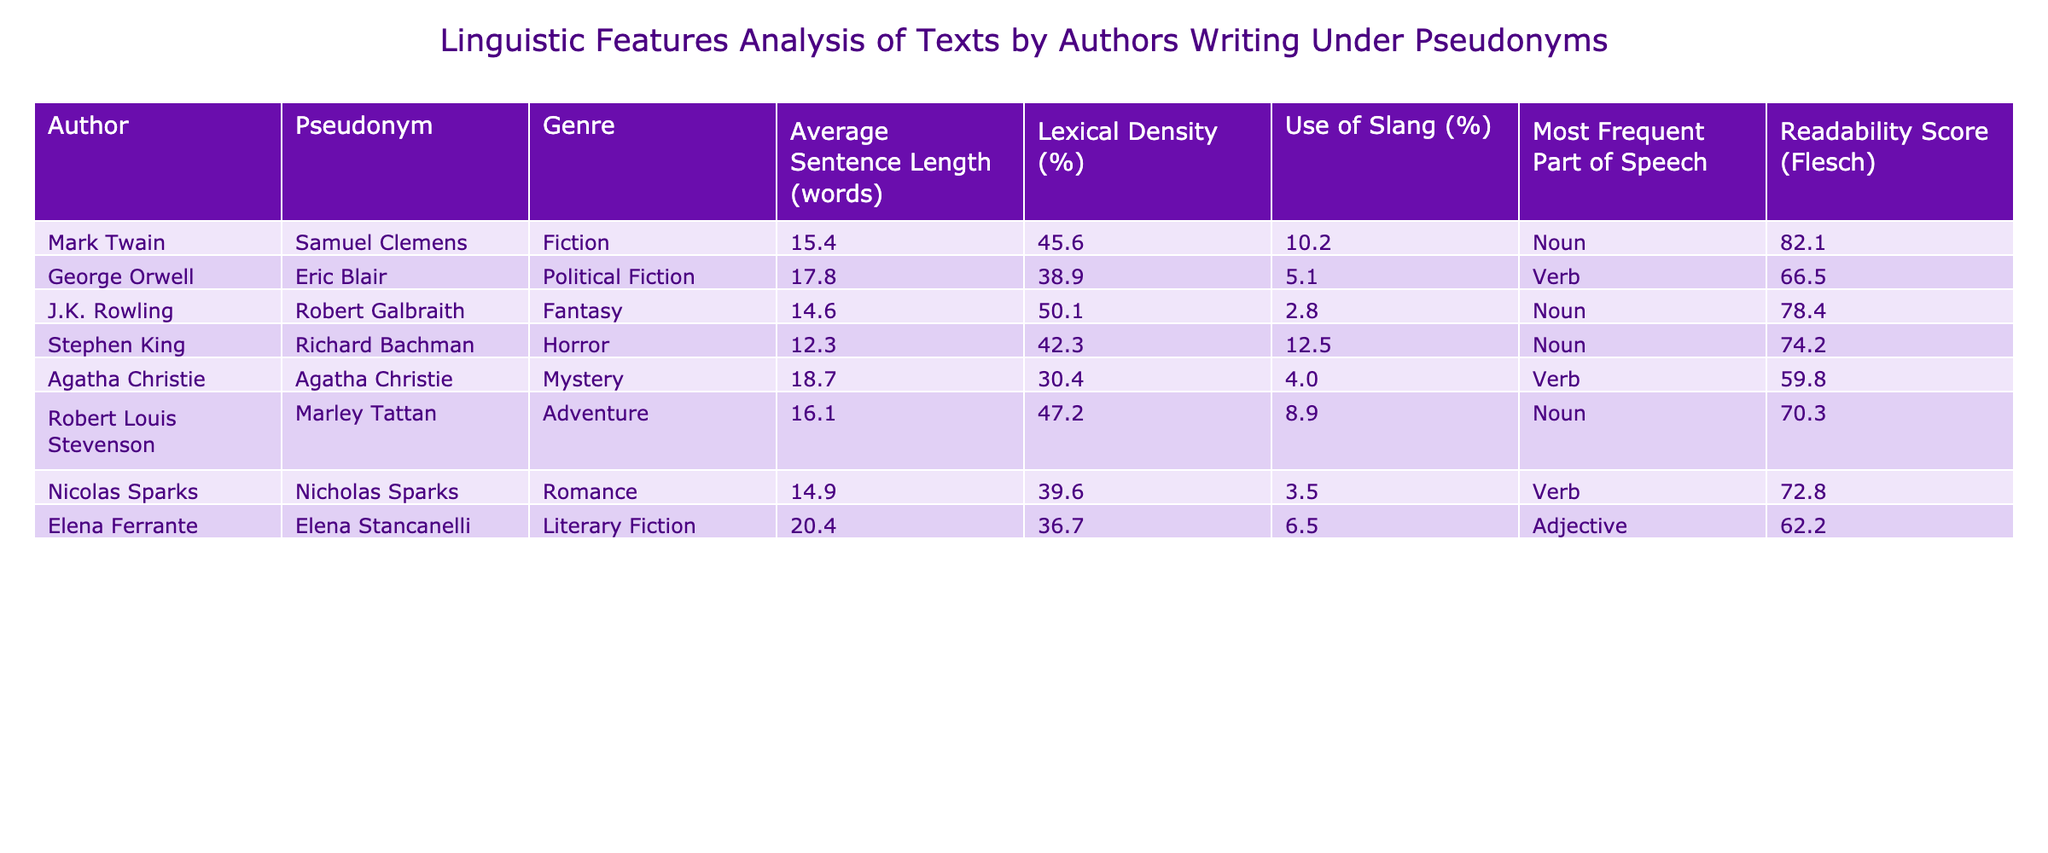What is the average sentence length for J.K. Rowling's pseudonym? According to the table, J.K. Rowling, using the pseudonym Robert Galbraith, has an average sentence length of 14.6 words.
Answer: 14.6 Which genre has the highest readability score? By comparing the readability scores across all genres in the table, the highest score is 82.1 for Mark Twain's work in Fiction.
Answer: 82.1 Does Elena Ferrante use more slang compared to Stephen King? The table indicates that Elena Ferrante (6.5%) uses more slang than Stephen King (12.5%). Hence, the statement is false.
Answer: No What is the difference in lexical density between Agatha Christie and Robert Louis Stevenson? Agatha Christie has a lexical density of 30.4%, while Robert Louis Stevenson has 47.2%. The difference is calculated as 47.2 - 30.4 = 16.8.
Answer: 16.8 Which author has the lowest average sentence length in the horror genre? In the table, Stephen King, writing as Richard Bachman, has the lowest average sentence length of 12.3 words among the listed authors in the horror genre.
Answer: 12.3 Is the most frequent part of speech for George Orwell a noun? The table shows that George Orwell's most frequent part of speech is a verb, hence the statement is false.
Answer: No What is the average readability score for the authors writing under a pseudonym? The readability scores are 82.1, 66.5, 78.4, 74.2, 59.8, 70.3, 72.8, and 62.2. To find the average, add these scores together (82.1 + 66.5 + 78.4 + 74.2 + 59.8 + 70.3 + 72.8 + 62.2 = 586.3) and divide by 8, resulting in an average readability score of 73.29.
Answer: 73.3 Which author writing under a pseudonym has the highest use of slang and in what genre? The author with the highest use of slang is Stephen King, writing as Richard Bachman, with 12.5% in the horror genre.
Answer: Stephen King, Horror, 12.5% How many authors in the table have a readability score below 70? From the table, the authors with a readability score below 70 are Agatha Christie (59.8), Elena Ferrante (62.2), and George Orwell (66.5), totaling three authors.
Answer: 3 